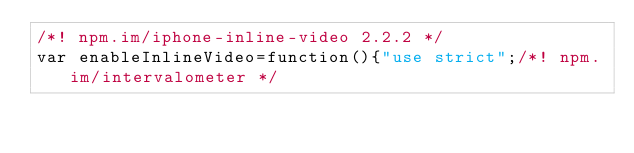Convert code to text. <code><loc_0><loc_0><loc_500><loc_500><_JavaScript_>/*! npm.im/iphone-inline-video 2.2.2 */
var enableInlineVideo=function(){"use strict";/*! npm.im/intervalometer */</code> 